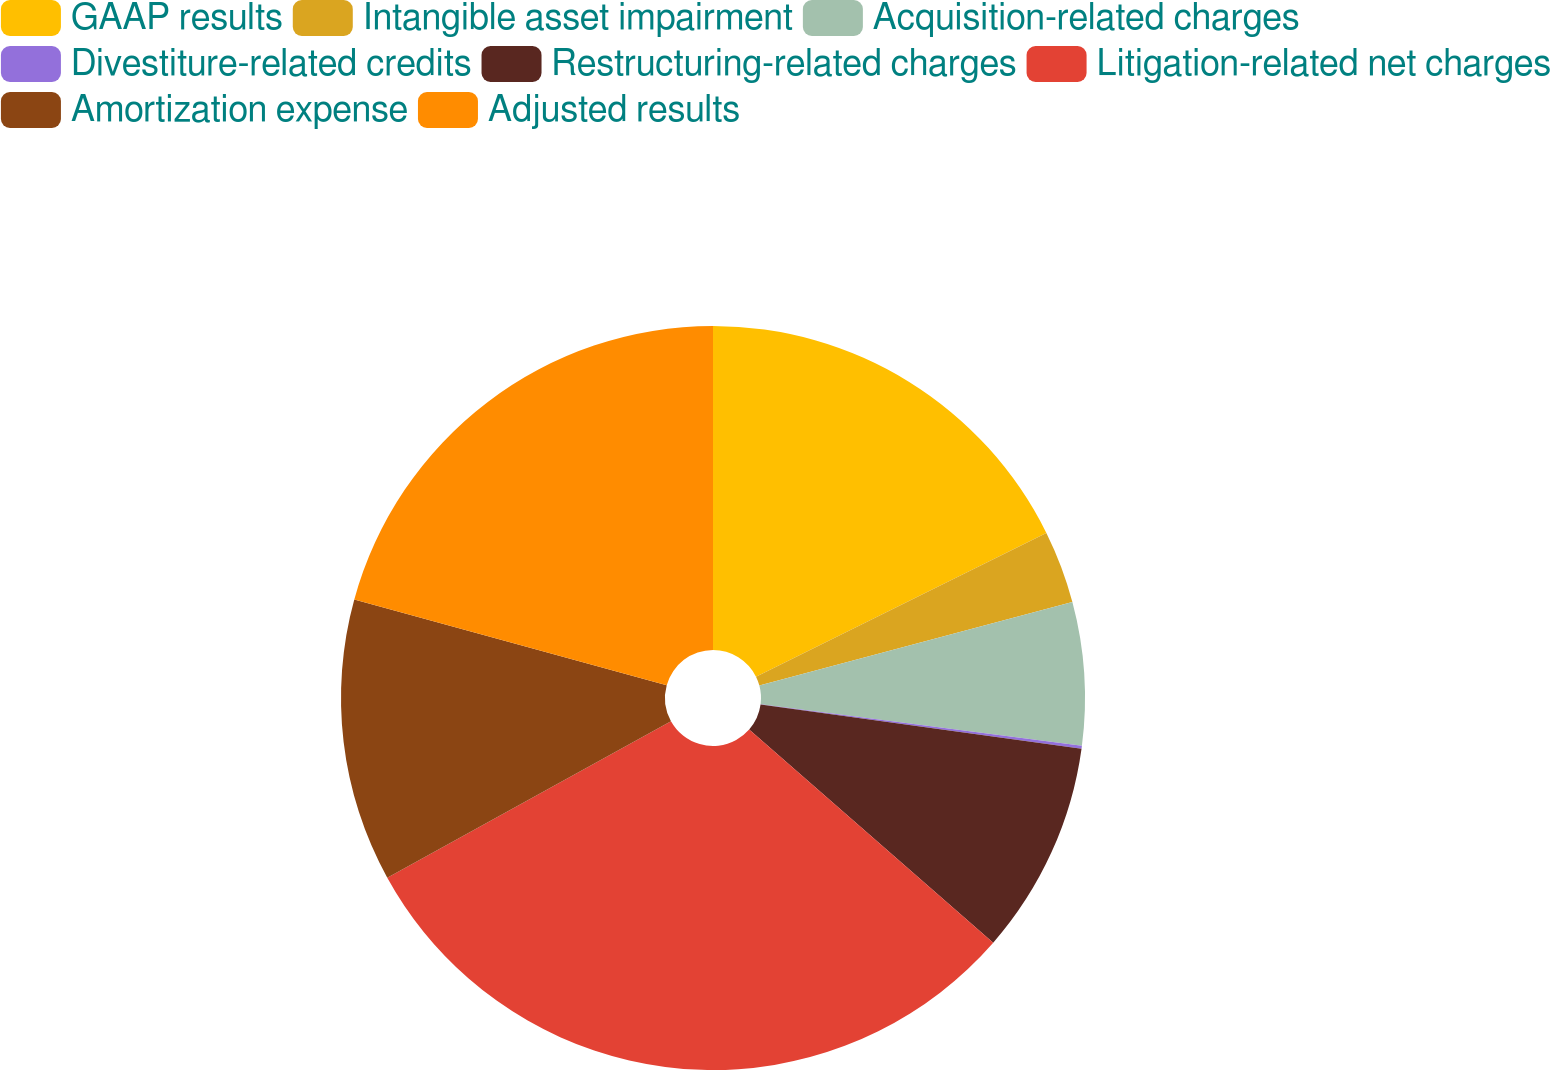Convert chart. <chart><loc_0><loc_0><loc_500><loc_500><pie_chart><fcel>GAAP results<fcel>Intangible asset impairment<fcel>Acquisition-related charges<fcel>Divestiture-related credits<fcel>Restructuring-related charges<fcel>Litigation-related net charges<fcel>Amortization expense<fcel>Adjusted results<nl><fcel>17.68%<fcel>3.16%<fcel>6.21%<fcel>0.12%<fcel>9.25%<fcel>30.55%<fcel>12.29%<fcel>20.73%<nl></chart> 